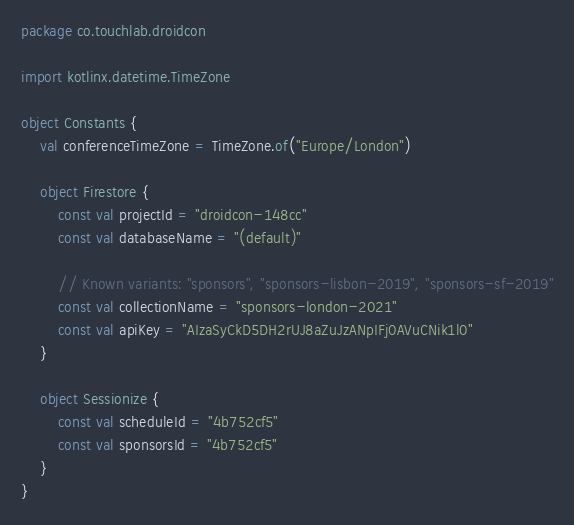<code> <loc_0><loc_0><loc_500><loc_500><_Kotlin_>package co.touchlab.droidcon

import kotlinx.datetime.TimeZone

object Constants {
    val conferenceTimeZone = TimeZone.of("Europe/London")

    object Firestore {
        const val projectId = "droidcon-148cc"
        const val databaseName = "(default)"

        // Known variants: "sponsors", "sponsors-lisbon-2019", "sponsors-sf-2019"
        const val collectionName = "sponsors-london-2021"
        const val apiKey = "AIzaSyCkD5DH2rUJ8aZuJzANpIFj0AVuCNik1l0"
    }

    object Sessionize {
        const val scheduleId = "4b752cf5"
        const val sponsorsId = "4b752cf5"
    }
}</code> 